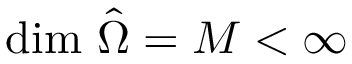<formula> <loc_0><loc_0><loc_500><loc_500>d i m \ \hat { \Omega } = M < \infty</formula> 